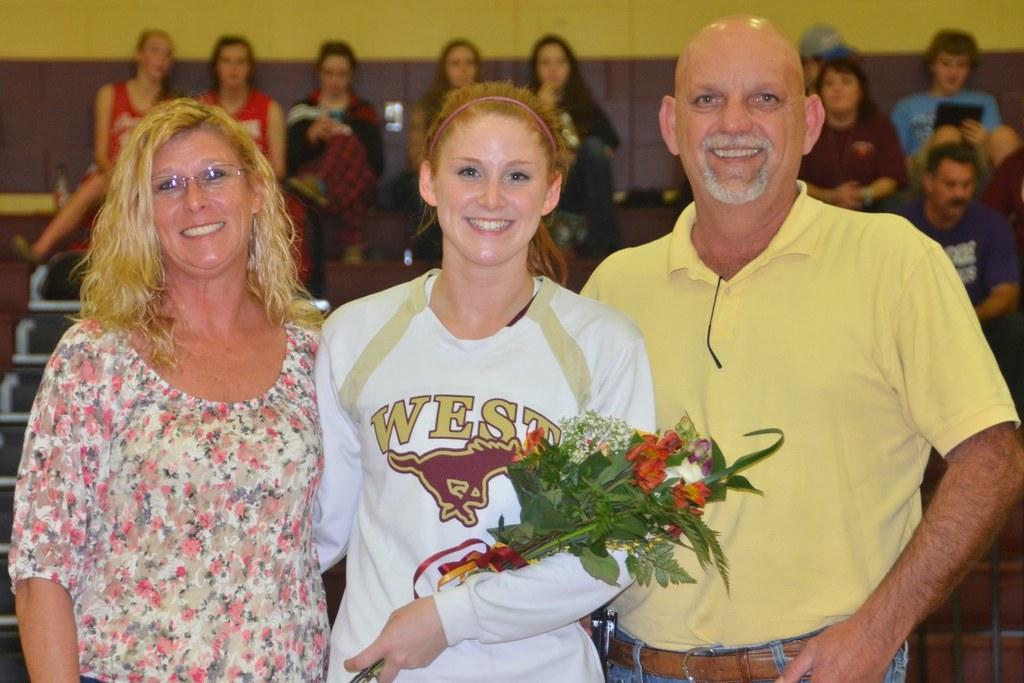Describe this image in one or two sentences. In this picture I can see three persons standing and smiling, a person holding a bouquet, and in the background there are group of people sitting on the chairs and there is a wall. 